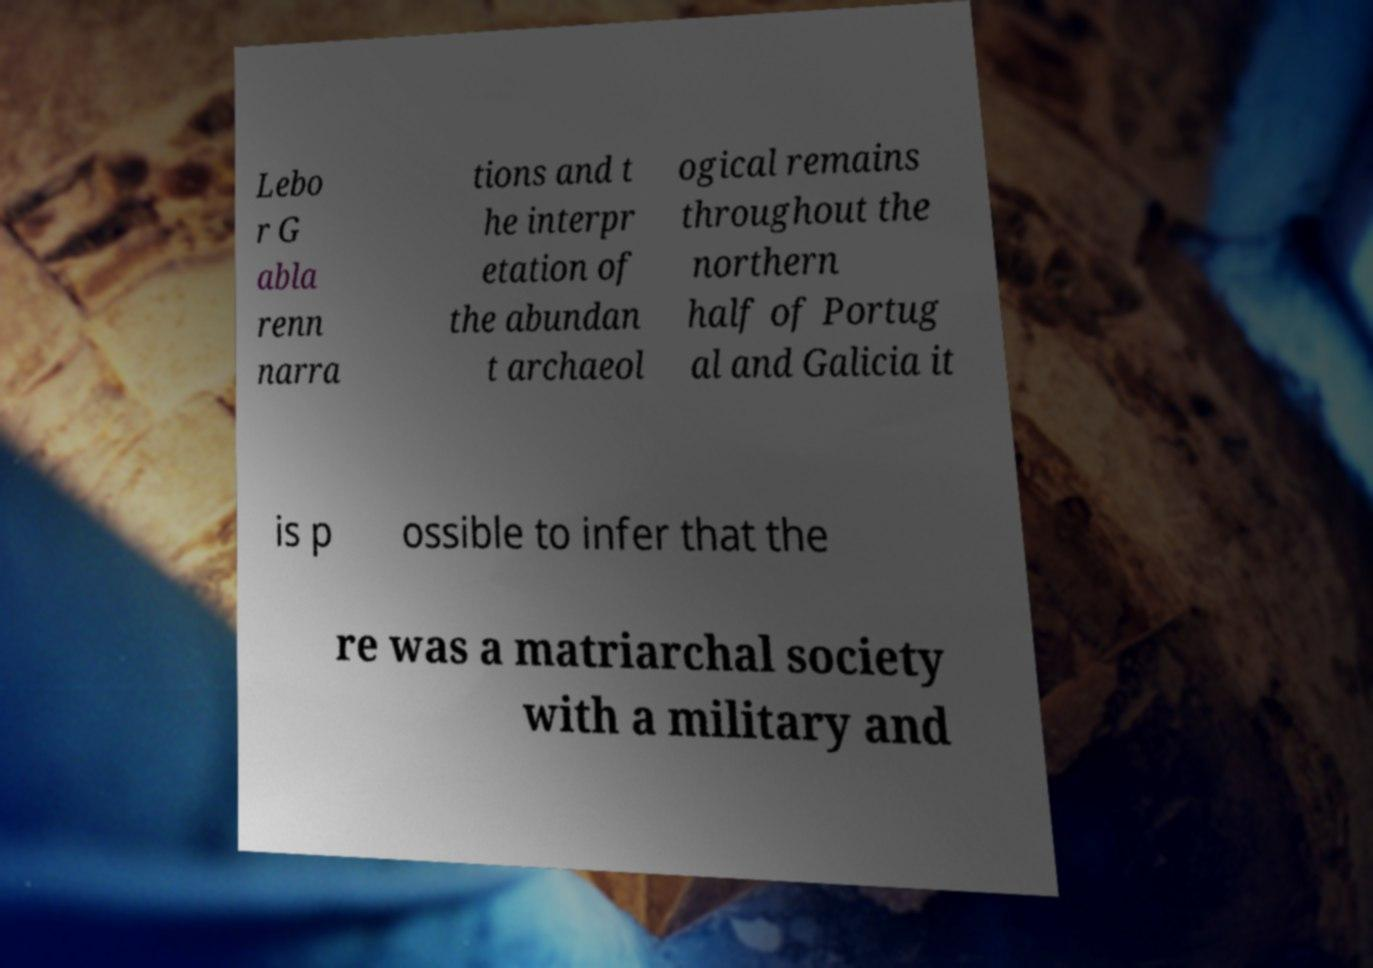Could you extract and type out the text from this image? Lebo r G abla renn narra tions and t he interpr etation of the abundan t archaeol ogical remains throughout the northern half of Portug al and Galicia it is p ossible to infer that the re was a matriarchal society with a military and 